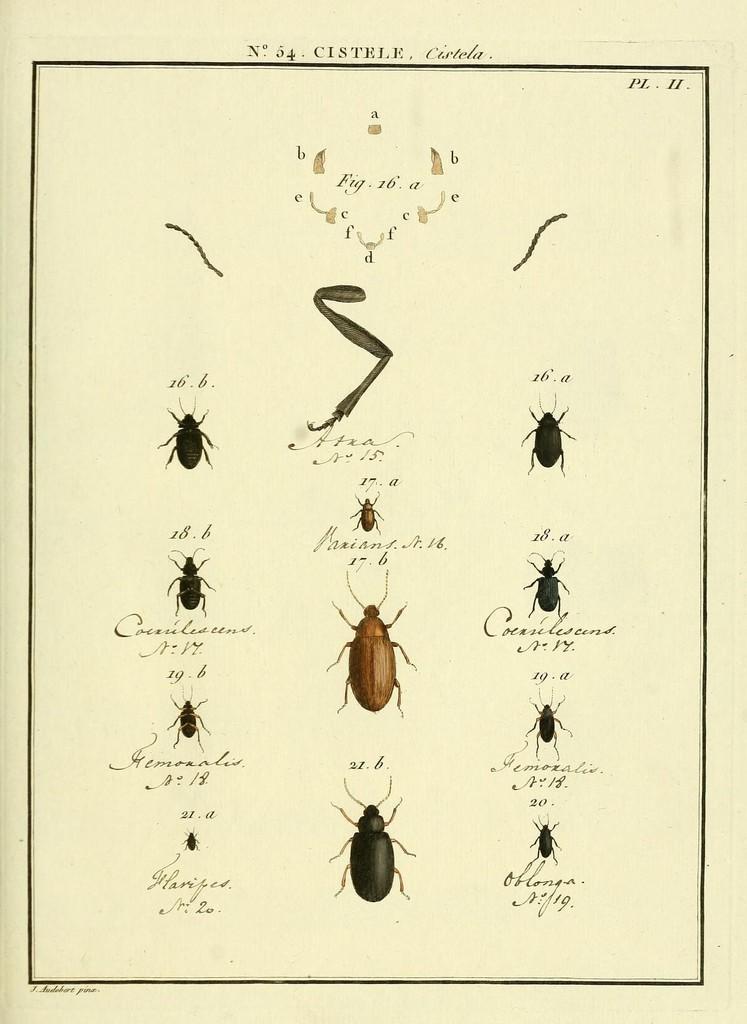Could you give a brief overview of what you see in this image? In this image, we can see a wall chart contains depiction of bugs and some text. 